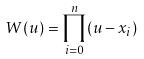Convert formula to latex. <formula><loc_0><loc_0><loc_500><loc_500>W ( u ) = \prod _ { i = 0 } ^ { n } ( u - x _ { i } )</formula> 